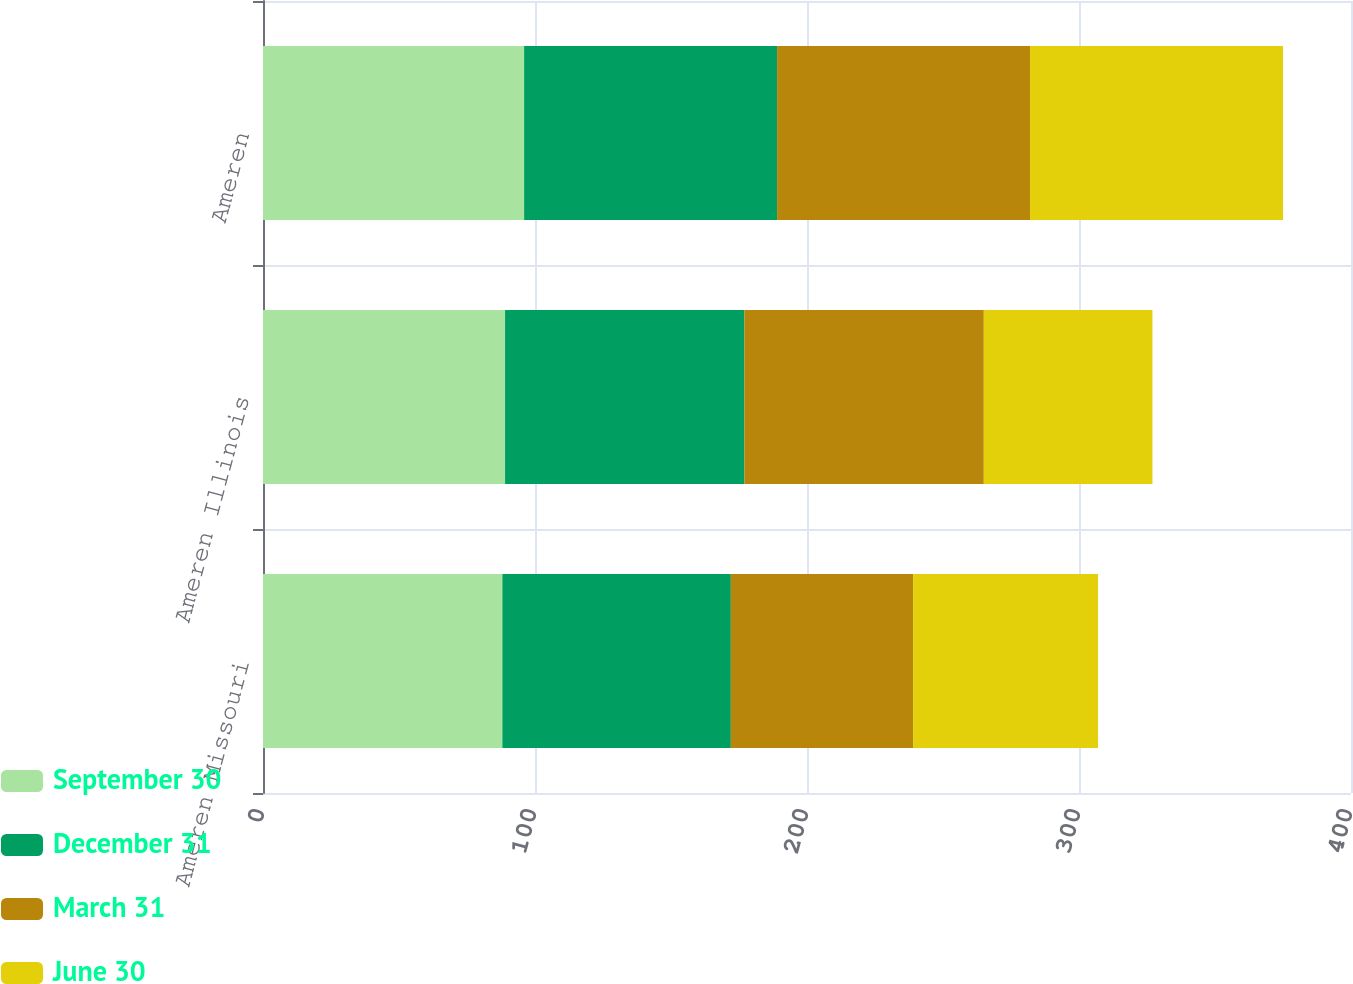Convert chart to OTSL. <chart><loc_0><loc_0><loc_500><loc_500><stacked_bar_chart><ecel><fcel>Ameren Missouri<fcel>Ameren Illinois<fcel>Ameren<nl><fcel>September 30<fcel>88<fcel>89<fcel>96<nl><fcel>December 31<fcel>84<fcel>88<fcel>93<nl><fcel>March 31<fcel>67<fcel>88<fcel>93<nl><fcel>June 30<fcel>68<fcel>62<fcel>93<nl></chart> 